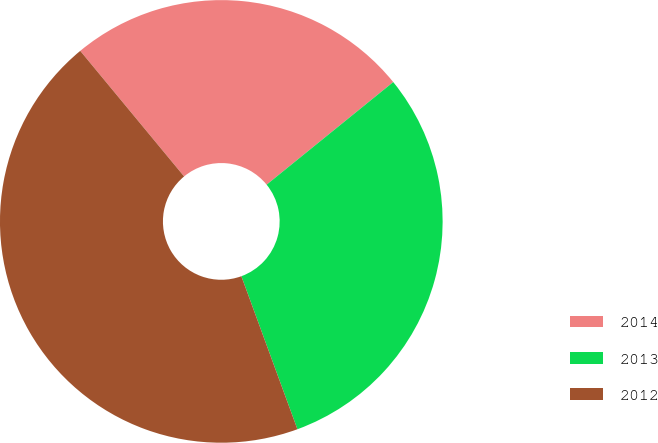<chart> <loc_0><loc_0><loc_500><loc_500><pie_chart><fcel>2014<fcel>2013<fcel>2012<nl><fcel>25.16%<fcel>30.25%<fcel>44.59%<nl></chart> 